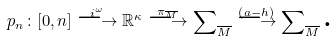<formula> <loc_0><loc_0><loc_500><loc_500>p _ { n } \colon [ 0 , n ] \overset { i ^ { \omega } } { \longrightarrow } \mathbb { R } ^ { \kappa } \overset { \pi _ { \overline { M } } } { \longrightarrow } \sum \nolimits _ { \overline { M } } \overset { \left ( a - h \right ) } { \longrightarrow } \sum \nolimits _ { \overline { M } } \text {.}</formula> 